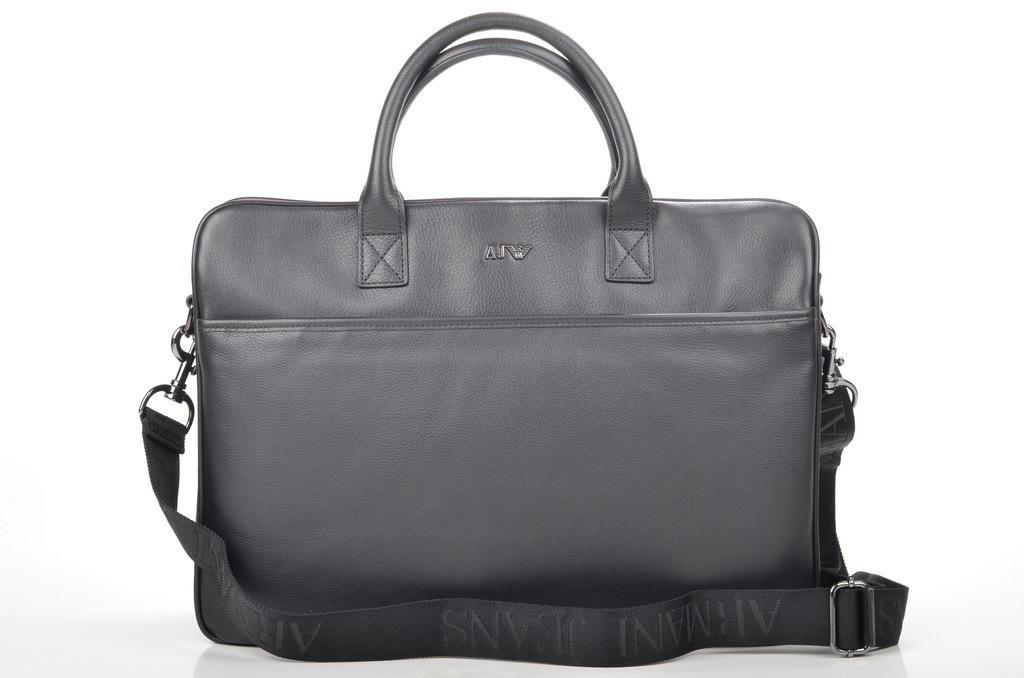Could you give a brief overview of what you see in this image? There is a black bag and the background is white in color. 